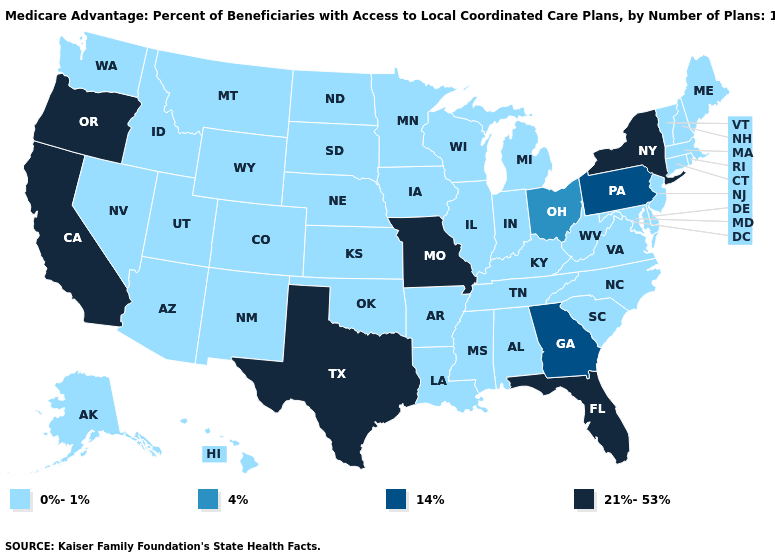Name the states that have a value in the range 14%?
Write a very short answer. Georgia, Pennsylvania. What is the value of North Dakota?
Give a very brief answer. 0%-1%. What is the value of Mississippi?
Concise answer only. 0%-1%. Name the states that have a value in the range 0%-1%?
Quick response, please. Alaska, Alabama, Arkansas, Arizona, Colorado, Connecticut, Delaware, Hawaii, Iowa, Idaho, Illinois, Indiana, Kansas, Kentucky, Louisiana, Massachusetts, Maryland, Maine, Michigan, Minnesota, Mississippi, Montana, North Carolina, North Dakota, Nebraska, New Hampshire, New Jersey, New Mexico, Nevada, Oklahoma, Rhode Island, South Carolina, South Dakota, Tennessee, Utah, Virginia, Vermont, Washington, Wisconsin, West Virginia, Wyoming. Which states have the highest value in the USA?
Give a very brief answer. California, Florida, Missouri, New York, Oregon, Texas. Name the states that have a value in the range 4%?
Be succinct. Ohio. Among the states that border Utah , which have the lowest value?
Short answer required. Arizona, Colorado, Idaho, New Mexico, Nevada, Wyoming. Does Colorado have the lowest value in the West?
Write a very short answer. Yes. Does Vermont have the highest value in the Northeast?
Concise answer only. No. What is the value of Illinois?
Short answer required. 0%-1%. What is the highest value in states that border Kentucky?
Short answer required. 21%-53%. Among the states that border Vermont , does New York have the highest value?
Give a very brief answer. Yes. Does Alaska have the highest value in the USA?
Keep it brief. No. What is the highest value in the West ?
Answer briefly. 21%-53%. 